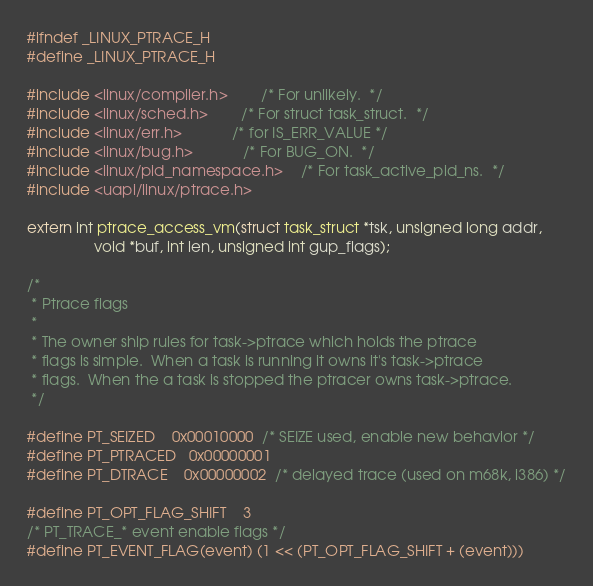<code> <loc_0><loc_0><loc_500><loc_500><_C_>#ifndef _LINUX_PTRACE_H
#define _LINUX_PTRACE_H

#include <linux/compiler.h>		/* For unlikely.  */
#include <linux/sched.h>		/* For struct task_struct.  */
#include <linux/err.h>			/* for IS_ERR_VALUE */
#include <linux/bug.h>			/* For BUG_ON.  */
#include <linux/pid_namespace.h>	/* For task_active_pid_ns.  */
#include <uapi/linux/ptrace.h>

extern int ptrace_access_vm(struct task_struct *tsk, unsigned long addr,
			    void *buf, int len, unsigned int gup_flags);

/*
 * Ptrace flags
 *
 * The owner ship rules for task->ptrace which holds the ptrace
 * flags is simple.  When a task is running it owns it's task->ptrace
 * flags.  When the a task is stopped the ptracer owns task->ptrace.
 */

#define PT_SEIZED	0x00010000	/* SEIZE used, enable new behavior */
#define PT_PTRACED	0x00000001
#define PT_DTRACE	0x00000002	/* delayed trace (used on m68k, i386) */

#define PT_OPT_FLAG_SHIFT	3
/* PT_TRACE_* event enable flags */
#define PT_EVENT_FLAG(event)	(1 << (PT_OPT_FLAG_SHIFT + (event)))</code> 